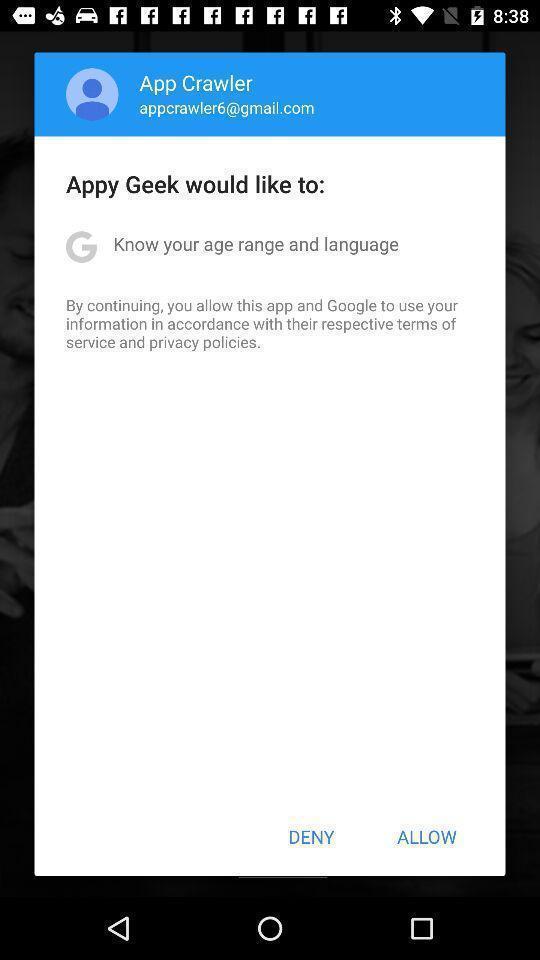Summarize the main components in this picture. Pop-up shows to continue with social application. 